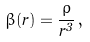<formula> <loc_0><loc_0><loc_500><loc_500>\beta ( r ) = \frac { \rho } { r ^ { 3 } } \, ,</formula> 